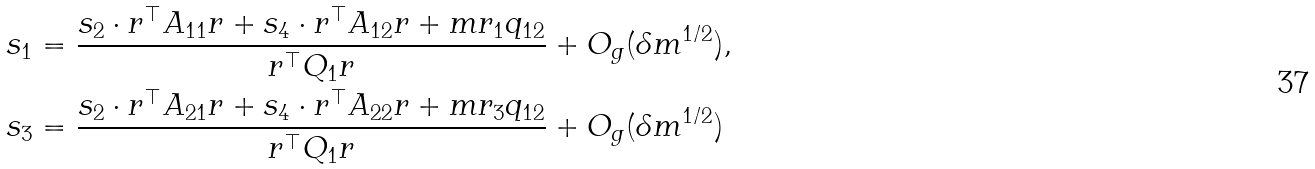Convert formula to latex. <formula><loc_0><loc_0><loc_500><loc_500>s _ { 1 } & = \frac { s _ { 2 } \cdot { r } ^ { \top } A _ { 1 1 } { r } + s _ { 4 } \cdot { r } ^ { \top } A _ { 1 2 } { r } + m r _ { 1 } q _ { 1 2 } } { { r } ^ { \top } Q _ { 1 } { r } } + O _ { g } ( \delta m ^ { 1 / 2 } ) , \\ s _ { 3 } & = \frac { s _ { 2 } \cdot { r } ^ { \top } A _ { 2 1 } { r } + s _ { 4 } \cdot { r } ^ { \top } A _ { 2 2 } { r } + m r _ { 3 } q _ { 1 2 } } { { r } ^ { \top } Q _ { 1 } { r } } + O _ { g } ( \delta m ^ { 1 / 2 } )</formula> 